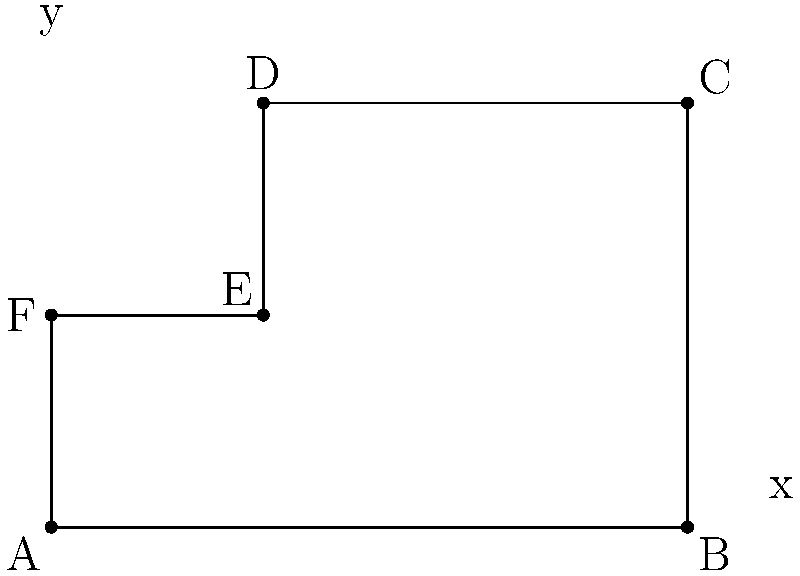In our library's new reading nook, we've designed an irregularly shaped area to accommodate various seating arrangements. The shape of this nook can be represented on a coordinate plane, where each unit represents 1 meter. The vertices of the shape are A(0,0), B(6,0), C(6,4), D(2,4), E(2,2), and F(0,2). What is the total area of this reading nook in square meters? To find the area of this irregular shape, we can divide it into rectangles and calculate their areas:

1. First, let's divide the shape into two rectangles:
   Rectangle 1: ABCF
   Rectangle 2: DEFC

2. Calculate the area of Rectangle 1 (ABCF):
   Width = 6 - 0 = 6 meters
   Height = 2 - 0 = 2 meters
   Area of Rectangle 1 = $6 \times 2 = 12$ square meters

3. Calculate the area of Rectangle 2 (DEFC):
   Width = 2 - 0 = 2 meters
   Height = 4 - 2 = 2 meters
   Area of Rectangle 2 = $2 \times 2 = 4$ square meters

4. The total area is the sum of these two rectangles:
   Total Area = Area of Rectangle 1 + Area of Rectangle 2
               = $12 + 4 = 16$ square meters

Therefore, the total area of the reading nook is 16 square meters.
Answer: 16 square meters 